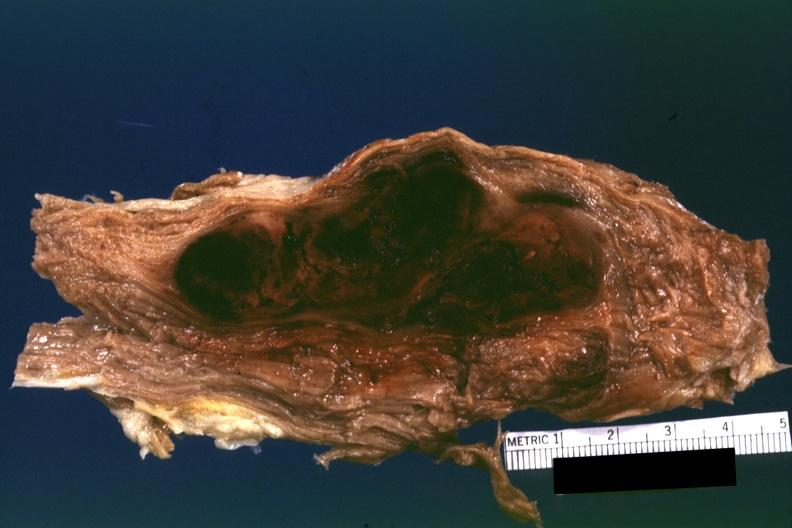does this image show sectioned muscle partially fixed but color ok i do not have protocol with diagnosis?
Answer the question using a single word or phrase. Yes 